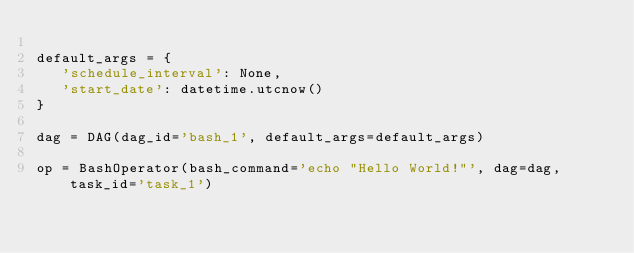Convert code to text. <code><loc_0><loc_0><loc_500><loc_500><_Python_>
default_args = {
   'schedule_interval': None,
   'start_date': datetime.utcnow()
}

dag = DAG(dag_id='bash_1', default_args=default_args)

op = BashOperator(bash_command='echo "Hello World!"', dag=dag, task_id='task_1')
</code> 